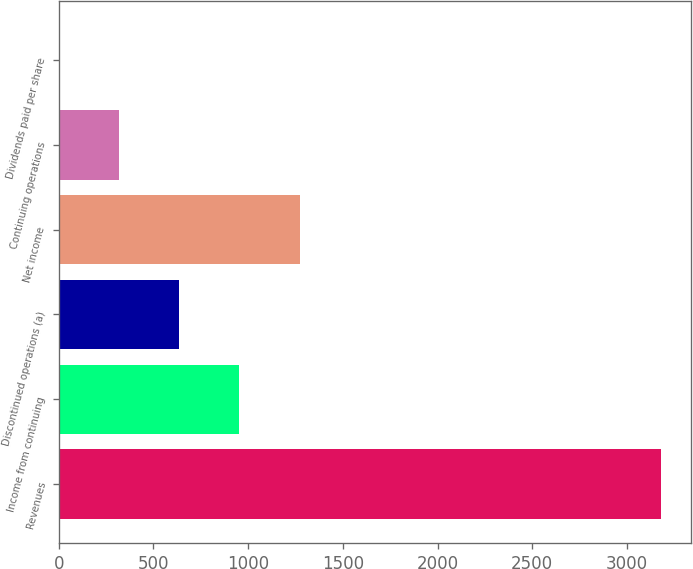Convert chart. <chart><loc_0><loc_0><loc_500><loc_500><bar_chart><fcel>Revenues<fcel>Income from continuing<fcel>Discontinued operations (a)<fcel>Net income<fcel>Continuing operations<fcel>Dividends paid per share<nl><fcel>3179<fcel>953.83<fcel>635.95<fcel>1271.71<fcel>318.07<fcel>0.19<nl></chart> 